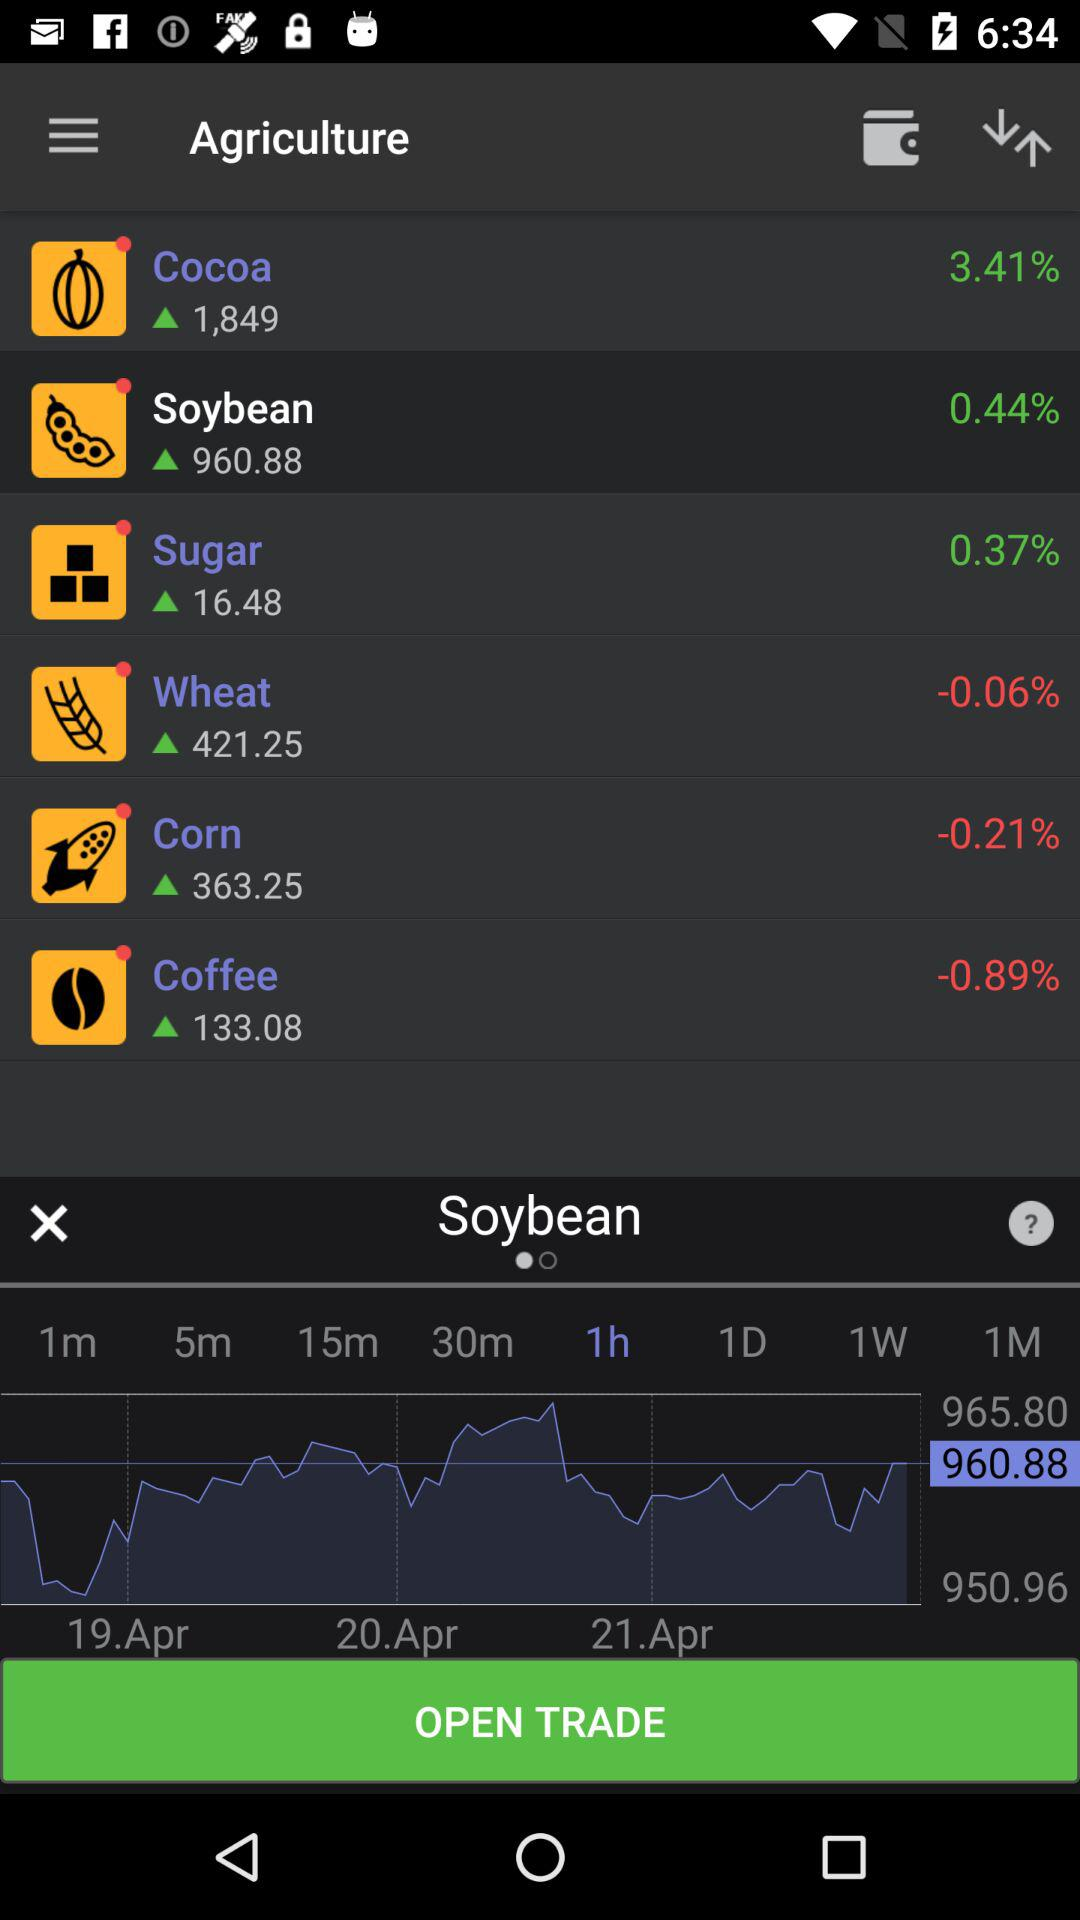What is the percentage decrease in wheat? The percentage decrease in wheat is -0.06. 